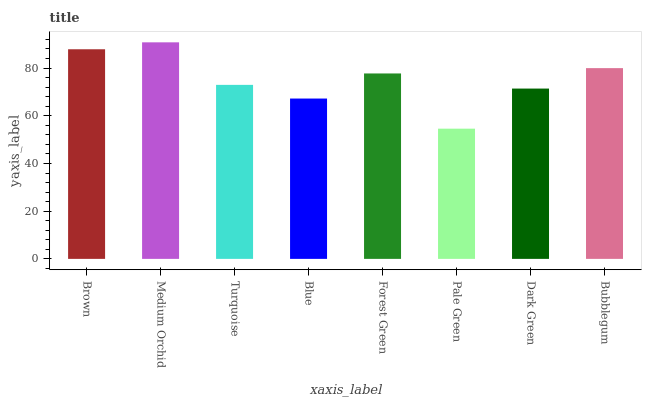Is Turquoise the minimum?
Answer yes or no. No. Is Turquoise the maximum?
Answer yes or no. No. Is Medium Orchid greater than Turquoise?
Answer yes or no. Yes. Is Turquoise less than Medium Orchid?
Answer yes or no. Yes. Is Turquoise greater than Medium Orchid?
Answer yes or no. No. Is Medium Orchid less than Turquoise?
Answer yes or no. No. Is Forest Green the high median?
Answer yes or no. Yes. Is Turquoise the low median?
Answer yes or no. Yes. Is Brown the high median?
Answer yes or no. No. Is Medium Orchid the low median?
Answer yes or no. No. 